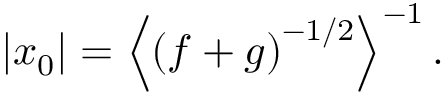<formula> <loc_0><loc_0><loc_500><loc_500>\left | x _ { 0 } \right | = \left \langle \left ( f + g \right ) ^ { - 1 / 2 } \right \rangle ^ { - 1 } .</formula> 